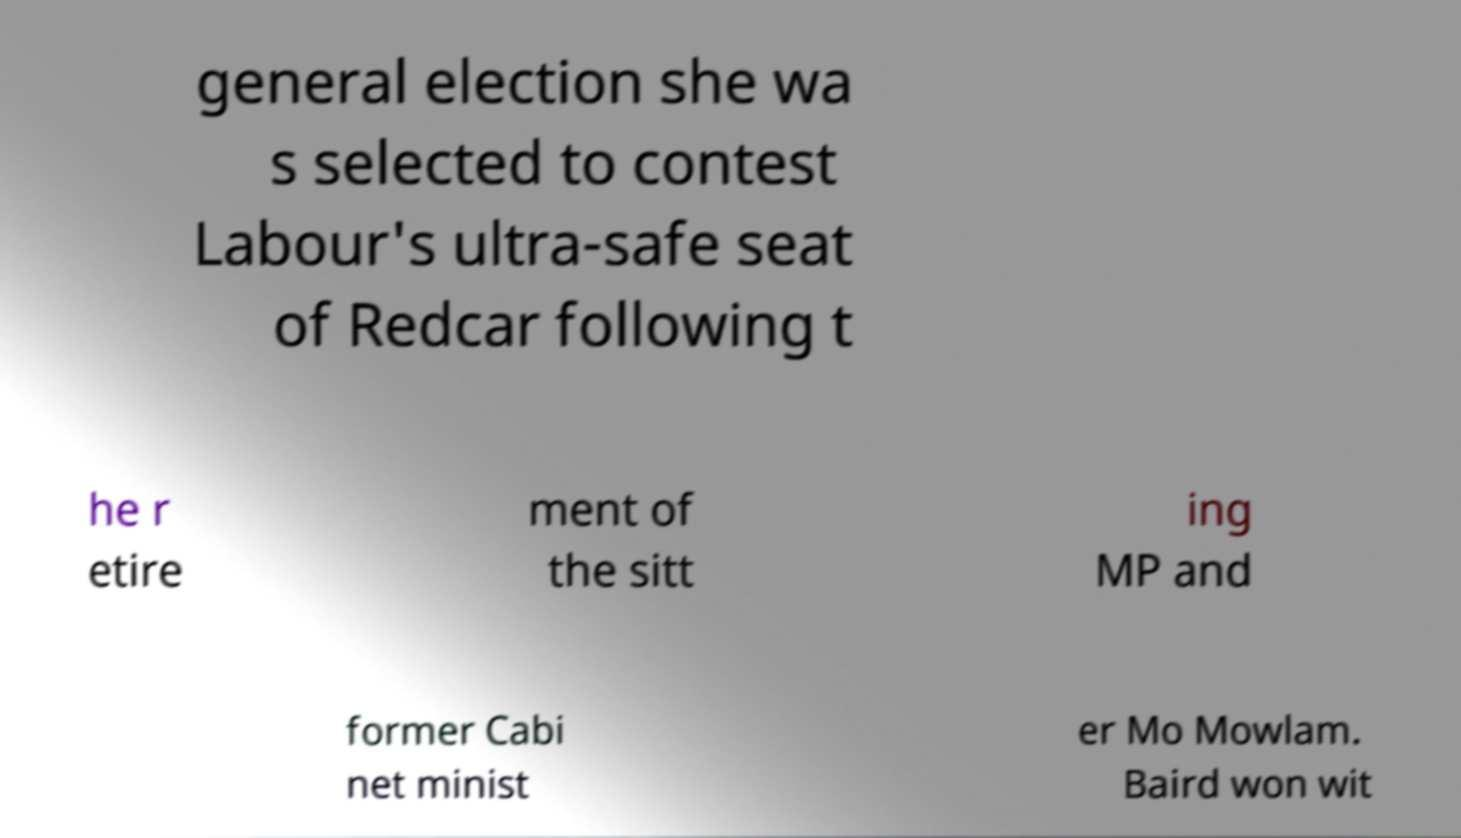Can you read and provide the text displayed in the image?This photo seems to have some interesting text. Can you extract and type it out for me? general election she wa s selected to contest Labour's ultra-safe seat of Redcar following t he r etire ment of the sitt ing MP and former Cabi net minist er Mo Mowlam. Baird won wit 